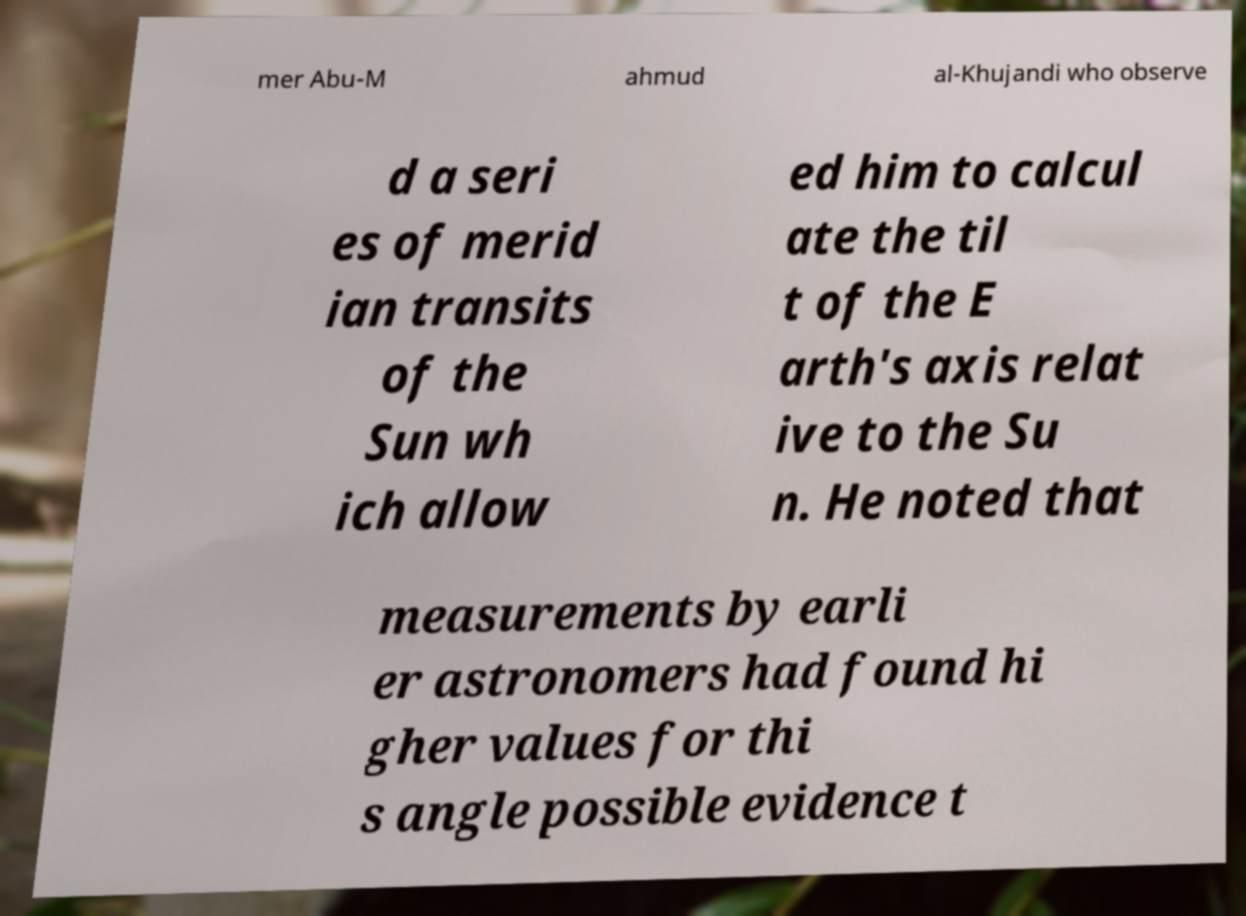For documentation purposes, I need the text within this image transcribed. Could you provide that? mer Abu-M ahmud al-Khujandi who observe d a seri es of merid ian transits of the Sun wh ich allow ed him to calcul ate the til t of the E arth's axis relat ive to the Su n. He noted that measurements by earli er astronomers had found hi gher values for thi s angle possible evidence t 